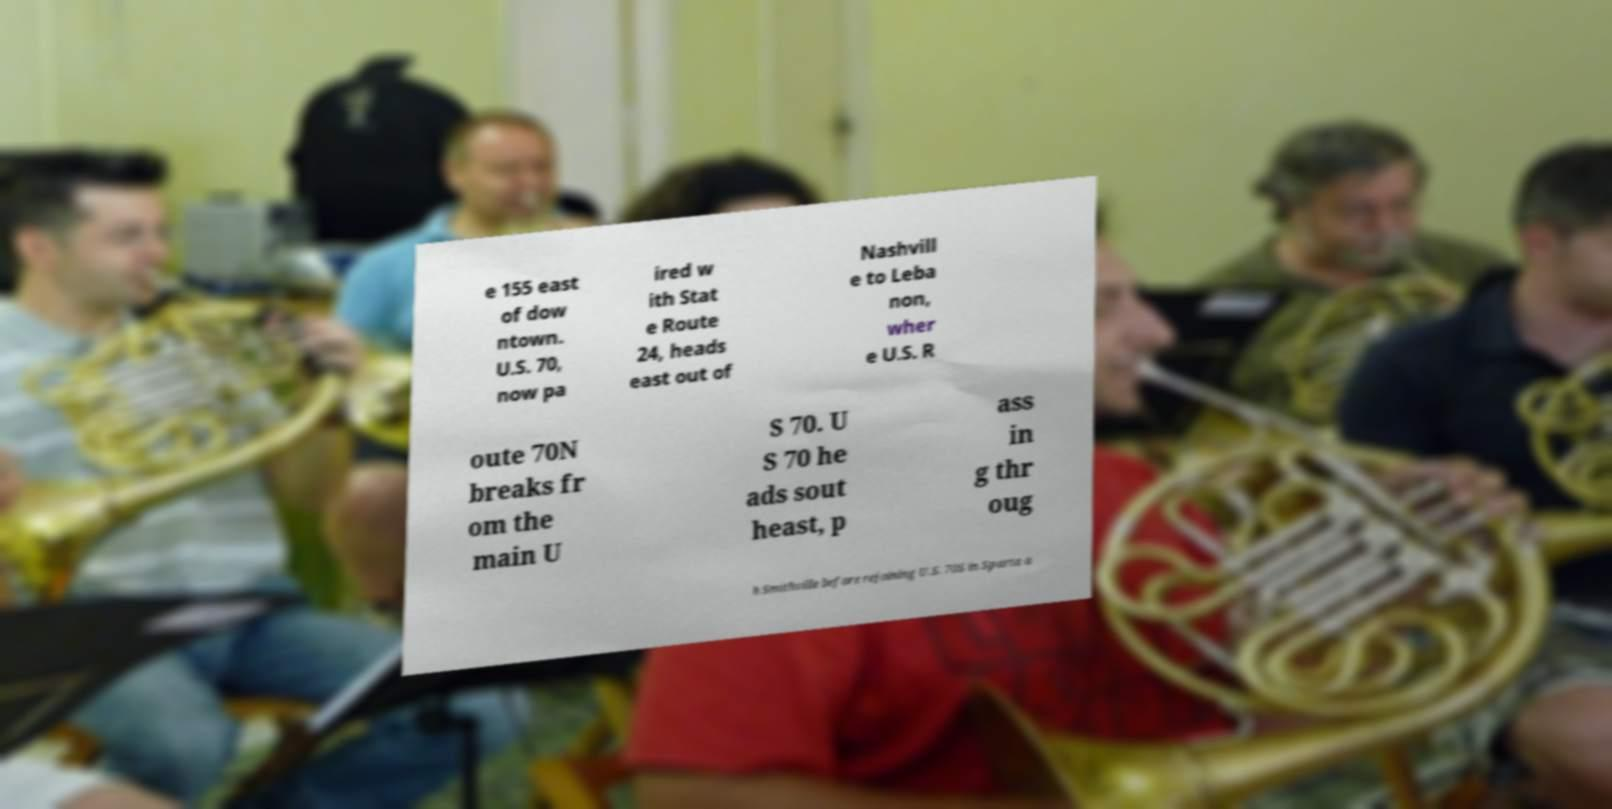I need the written content from this picture converted into text. Can you do that? e 155 east of dow ntown. U.S. 70, now pa ired w ith Stat e Route 24, heads east out of Nashvill e to Leba non, wher e U.S. R oute 70N breaks fr om the main U S 70. U S 70 he ads sout heast, p ass in g thr oug h Smithville before rejoining U.S. 70S in Sparta a 